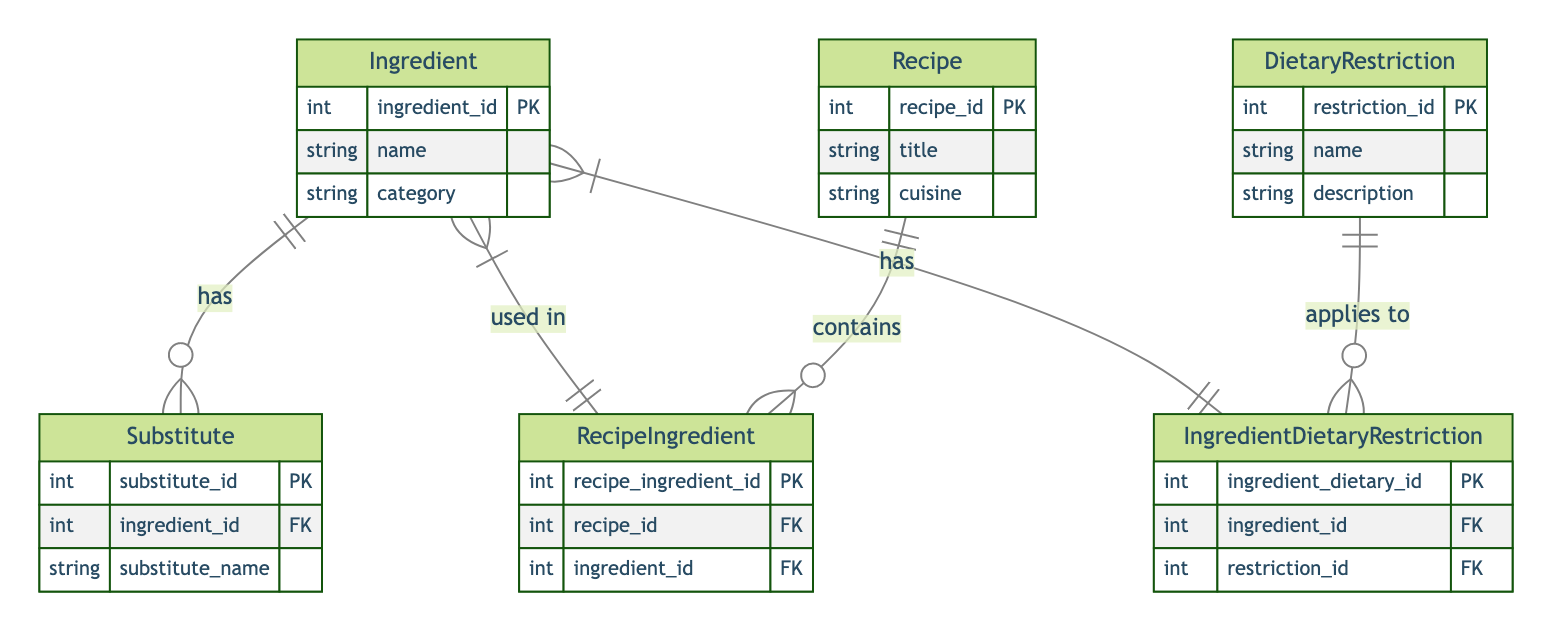What is the primary key of the Ingredient entity? The primary key for the Ingredient entity is "ingredient_id," which uniquely identifies each ingredient in the database.
Answer: ingredient_id How many entities are there in the diagram? There are six entities present in the diagram, including Ingredient, Substitute, Recipe, RecipeIngredient, DietaryRestriction, and IngredientDietaryRestriction.
Answer: six What type of relationship exists between Recipe and Ingredient? The relationship between Recipe and Ingredient is a many-to-many relationship, as signified by the use of the RecipeIngredient linking table that allows a recipe to contain multiple ingredients and an ingredient to be used in multiple recipes.
Answer: many-to-many Which entity has a one-to-many relationship with Substitute? The Ingredient entity has a one-to-many relationship with the Substitute entity; specifically, each ingredient can have multiple substitutes associated with it.
Answer: Ingredient How many attributes does the DietaryRestriction entity have? The DietaryRestriction entity contains three attributes: restriction_id, name, and description, which provide necessary information about dietary restrictions.
Answer: three Which entities are linked through the IngredientDietaryRestriction table? The IngredientDietaryRestriction table links the Ingredient entity and the DietaryRestriction entity, creating a connection that allows ingredients to be associated with various dietary restrictions.
Answer: Ingredient and DietaryRestriction What is the maximum number of substitutes an ingredient can have according to the diagram? The diagram shows a one-to-many relationship between Ingredient and Substitute, indicating that an ingredient can have one or more substitutes; hence, there is no specified maximum in the diagram.
Answer: one or more How many relationships are depicted in the diagram? There are four relationships depicted in the diagram that illustrate the connections between the various entities, including one-to-many and many-to-many relationships.
Answer: four What does the RecipeIngredient entity represent in the diagram? The RecipeIngredient entity serves as a linking table that connects the Recipe and Ingredient entities, indicating which ingredients are used in specific recipes.
Answer: linking table 